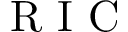<formula> <loc_0><loc_0><loc_500><loc_500>R I C</formula> 